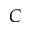<formula> <loc_0><loc_0><loc_500><loc_500>C</formula> 